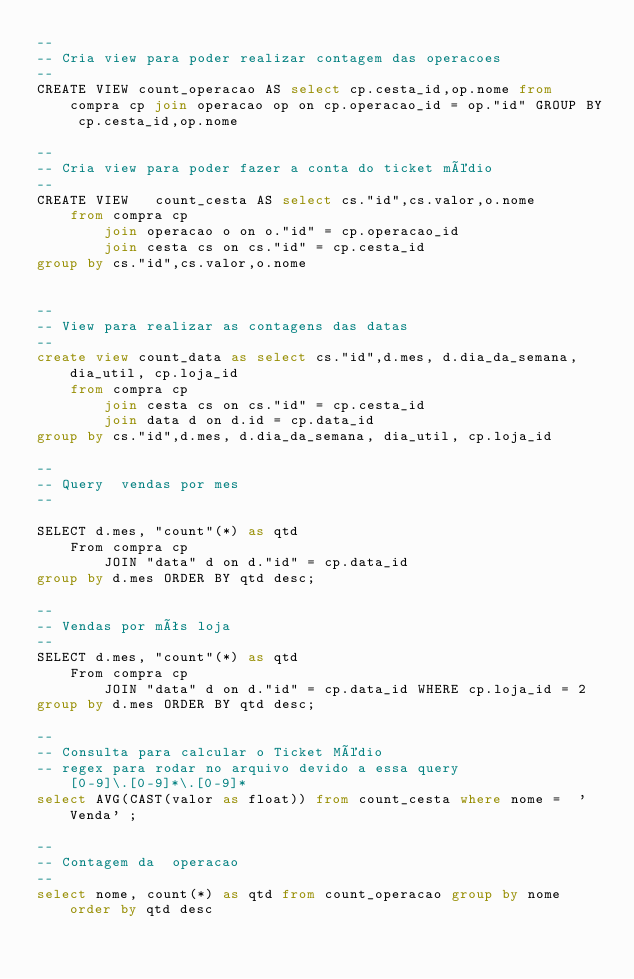Convert code to text. <code><loc_0><loc_0><loc_500><loc_500><_SQL_>--
-- Cria view para poder realizar contagem das operacoes
--
CREATE VIEW count_operacao AS select cp.cesta_id,op.nome from compra cp join operacao op on cp.operacao_id = op."id" GROUP BY cp.cesta_id,op.nome

--
-- Cria view para poder fazer a conta do ticket médio
--
CREATE VIEW   count_cesta AS select cs."id",cs.valor,o.nome 
	from compra cp 
		join operacao o on o."id" = cp.operacao_id 
		join cesta cs on cs."id" = cp.cesta_id
group by cs."id",cs.valor,o.nome


--
-- View para realizar as contagens das datas
--
create view count_data as select cs."id",d.mes, d.dia_da_semana, dia_util, cp.loja_id
	from compra cp 
		join cesta cs on cs."id" = cp.cesta_id
		join data d on d.id = cp.data_id
group by cs."id",d.mes, d.dia_da_semana, dia_util, cp.loja_id

--
-- Query  vendas por mes
--

SELECT d.mes, "count"(*) as qtd
	From compra cp 
		JOIN "data" d on d."id" = cp.data_id 
group by d.mes ORDER BY qtd desc;

--
-- Vendas por mês loja
-- 
SELECT d.mes, "count"(*) as qtd
	From compra cp 
		JOIN "data" d on d."id" = cp.data_id WHERE cp.loja_id = 2
group by d.mes ORDER BY qtd desc;

--
-- Consulta para calcular o Ticket Médio
-- regex para rodar no arquivo devido a essa query [0-9]\.[0-9]*\.[0-9]*
select AVG(CAST(valor as float)) from count_cesta where nome = 	'Venda'	;

--
-- Contagem da  operacao 
--
select nome, count(*) as qtd from count_operacao group by nome order by qtd desc</code> 